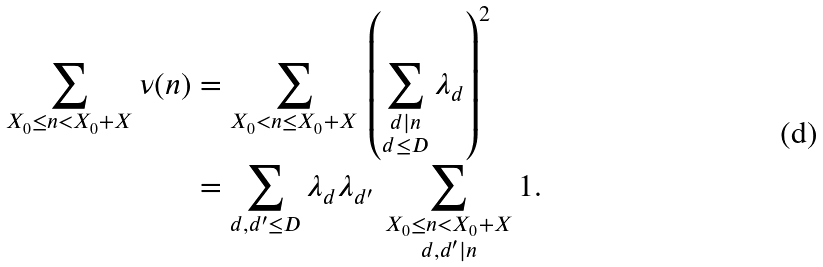Convert formula to latex. <formula><loc_0><loc_0><loc_500><loc_500>\sum _ { X _ { 0 } \leq n < X _ { 0 } + X } \nu ( n ) & = \sum _ { X _ { 0 } < n \leq X _ { 0 } + X } \, \left ( \sum _ { \substack { d | n \\ d \leq D } } \lambda _ { d } \right ) ^ { 2 } \\ & = \sum _ { d , d ^ { \prime } \leq D } \lambda _ { d } \lambda _ { d ^ { \prime } } \, \sum _ { \substack { X _ { 0 } \leq n < X _ { 0 } + X \\ d , d ^ { \prime } | n } } 1 .</formula> 